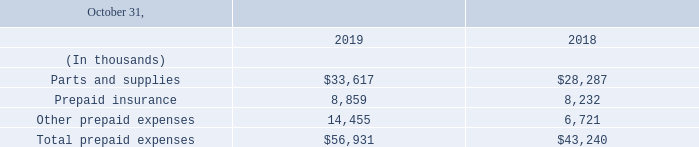4. Prepaid expenses
Prepaid expenses consisted of the following:
What is the value of Parts and supplies for fiscal years 2019 and 2018 respectively?
Answer scale should be: thousand. $33,617, $28,287. What is the value of Prepaid insurance for fiscal years 2019 and 2018 respectively?
Answer scale should be: thousand. 8,859, 8,232. What does the table contain data about? Prepaid expenses. What is the average Parts and supplies for fiscal years 2019 and 2018?
Answer scale should be: thousand. (33,617+ 28,287)/2
Answer: 30952. What is the average Prepaid insurance for fiscal years 2019 and 2018?
Answer scale should be: thousand. (8,859+ 8,232)/2
Answer: 8545.5. What is the change in Total prepaid expenses between fiscal years 2019 and 2018?
Answer scale should be: thousand. 56,931-43,240
Answer: 13691. 